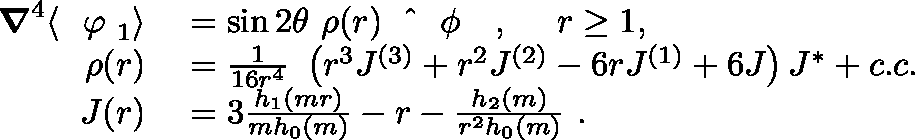<formula> <loc_0><loc_0><loc_500><loc_500>\begin{array} { r l } { { \nabla } ^ { 4 } \langle { \boldmath \varphi } _ { 1 } \rangle } & = \sin 2 \theta \rho ( r ) { \boldmath { { \phi } } } , r \geq 1 , } \\ { \rho ( r ) } & = \frac { 1 } { 1 6 r ^ { 4 } } \left ( r ^ { 3 } J ^ { ( 3 ) } + r ^ { 2 } J ^ { ( 2 ) } - 6 r J ^ { ( 1 ) } + 6 J \right ) J ^ { * } + c . c . } \\ { J ( r ) } & = 3 \frac { h _ { 1 } ( m r ) } { m h _ { 0 } ( m ) } - r - \frac { h _ { 2 } ( m ) } { r ^ { 2 } h _ { 0 } ( m ) } . } \end{array}</formula> 